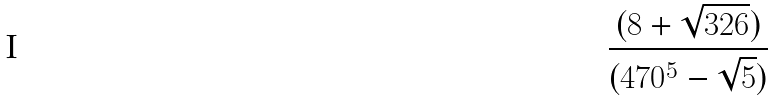<formula> <loc_0><loc_0><loc_500><loc_500>\frac { ( 8 + \sqrt { 3 2 6 } ) } { ( 4 7 0 ^ { 5 } - \sqrt { 5 } ) }</formula> 